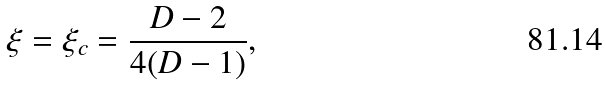<formula> <loc_0><loc_0><loc_500><loc_500>\xi = \xi _ { c } = \frac { D - 2 } { 4 ( D - 1 ) } ,</formula> 